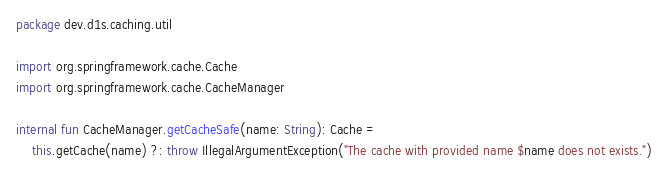Convert code to text. <code><loc_0><loc_0><loc_500><loc_500><_Kotlin_>package dev.d1s.caching.util

import org.springframework.cache.Cache
import org.springframework.cache.CacheManager

internal fun CacheManager.getCacheSafe(name: String): Cache =
    this.getCache(name) ?: throw IllegalArgumentException("The cache with provided name $name does not exists.")</code> 